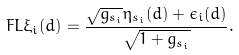Convert formula to latex. <formula><loc_0><loc_0><loc_500><loc_500>\ F L \xi _ { i } ( d ) = \frac { \sqrt { g _ { s _ { i } } } \eta _ { s _ { i } } ( d ) + \epsilon _ { i } ( d ) } { \sqrt { 1 + g _ { s _ { i } } } } .</formula> 